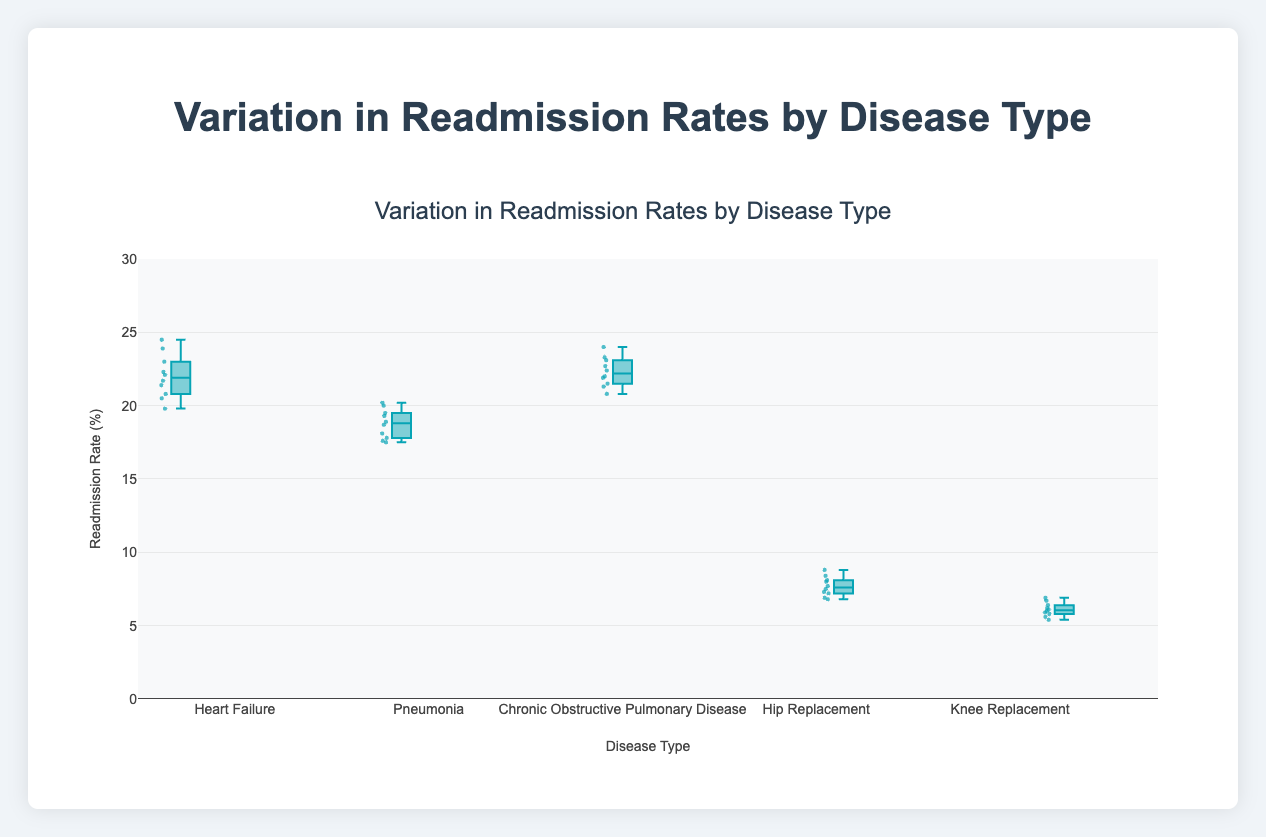What is the title of the figure? The title is prominently displayed at the top of the figure and typically summarizes what the figure is about.
Answer: Variation in Readmission Rates by Disease Type What disease has the highest median readmission rate? The median is indicated by the line inside each box. Look for the highest line amongst all boxes.
Answer: Heart Failure Which disease has the lowest variability in readmission rates? Variability can be judged by the length of the boxes (interquartile range). The shortest box represents the lowest variability.
Answer: Knee Replacement How do the readmission rates for Pneumonia compare to Hip Replacement? By looking at the boxes for Pneumonia and Hip Replacement, we can compare their medians and ranges.
Answer: Pneumonia has higher median and greater variability than Hip Replacement Which disease type has the most outliers? Outliers are typically plotted as individual points outside the main box. The disease type with the most such points has the most outliers.
Answer: Heart Failure What is the maximum readmission rate for Chronic Obstructive Pulmonary Disease? The maximum value is found at the top whisker of the box plot for Chronic Obstructive Pulmonary Disease.
Answer: 24.0% Is the median readmission rate for Hip Replacement greater than or less than the lower quartile for Heart Failure? Identify the median for Hip Replacement and the lower quartile for Heart Failure and then compare these values.
Answer: Less than What is the interquartile range (IQR) for Pneumonia? IQR is calculated as the difference between the upper quartile (75th percentile) and the lower quartile (25th percentile) of the data within the box plot.
Answer: Approx. 2.5% Are the readmission rates for Heart Failure generally higher than those for Pneumonia? By comparing the positions of the Heart Failure and Pneumonia boxes, we can observe their respective medians and ranges.
Answer: Yes Which disease type has the most consistent readmission rates around its median? Consistency can be inferred by the smaller interquartile range and fewer outliers. Assess which disease type meets these criteria.
Answer: Knee Replacement 